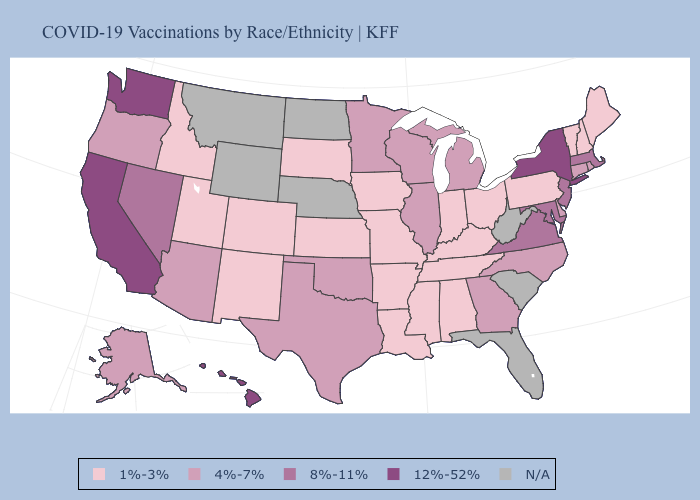Among the states that border New Hampshire , does Massachusetts have the highest value?
Quick response, please. Yes. Among the states that border Kansas , which have the lowest value?
Answer briefly. Colorado, Missouri. What is the highest value in the USA?
Answer briefly. 12%-52%. Among the states that border Georgia , does North Carolina have the lowest value?
Keep it brief. No. Which states have the highest value in the USA?
Write a very short answer. California, Hawaii, New York, Washington. What is the value of Florida?
Write a very short answer. N/A. Among the states that border Wyoming , which have the lowest value?
Be succinct. Colorado, Idaho, South Dakota, Utah. What is the highest value in the Northeast ?
Short answer required. 12%-52%. Does Hawaii have the highest value in the USA?
Answer briefly. Yes. Does California have the highest value in the USA?
Short answer required. Yes. Which states have the highest value in the USA?
Short answer required. California, Hawaii, New York, Washington. What is the value of New Jersey?
Be succinct. 8%-11%. Name the states that have a value in the range 8%-11%?
Keep it brief. Maryland, Massachusetts, Nevada, New Jersey, Virginia. What is the value of Montana?
Give a very brief answer. N/A. What is the value of Kansas?
Answer briefly. 1%-3%. 